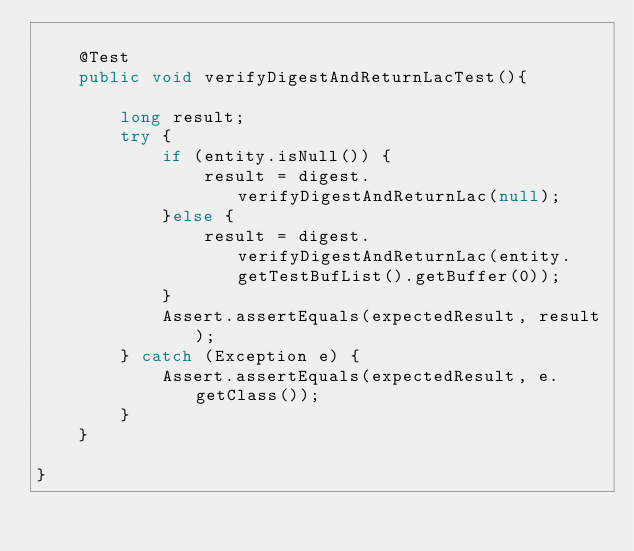Convert code to text. <code><loc_0><loc_0><loc_500><loc_500><_Java_>
	@Test
	public void verifyDigestAndReturnLacTest(){
		
		long result;
		try {
			if (entity.isNull()) {
				result = digest.verifyDigestAndReturnLac(null);
			}else {
				result = digest.verifyDigestAndReturnLac(entity.getTestBufList().getBuffer(0));
			}
			Assert.assertEquals(expectedResult, result);
		} catch (Exception e) {
			Assert.assertEquals(expectedResult, e.getClass());
		}
	}
	
}  


</code> 